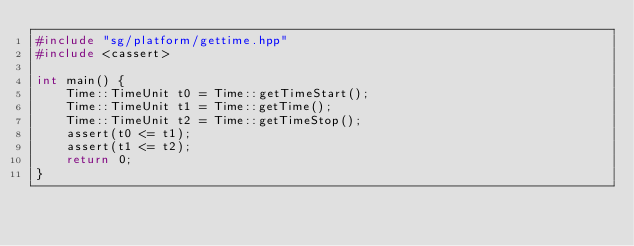Convert code to text. <code><loc_0><loc_0><loc_500><loc_500><_C++_>#include "sg/platform/gettime.hpp"
#include <cassert>

int main() {
    Time::TimeUnit t0 = Time::getTimeStart();
    Time::TimeUnit t1 = Time::getTime();
    Time::TimeUnit t2 = Time::getTimeStop();
    assert(t0 <= t1);
    assert(t1 <= t2);
    return 0;
}

</code> 